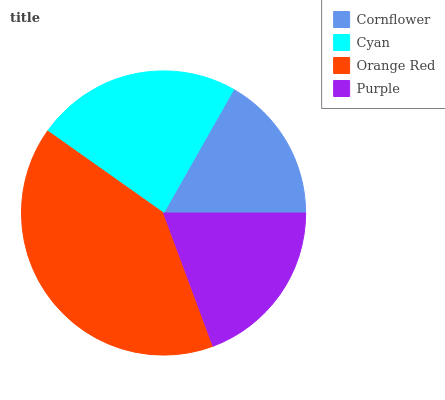Is Cornflower the minimum?
Answer yes or no. Yes. Is Orange Red the maximum?
Answer yes or no. Yes. Is Cyan the minimum?
Answer yes or no. No. Is Cyan the maximum?
Answer yes or no. No. Is Cyan greater than Cornflower?
Answer yes or no. Yes. Is Cornflower less than Cyan?
Answer yes or no. Yes. Is Cornflower greater than Cyan?
Answer yes or no. No. Is Cyan less than Cornflower?
Answer yes or no. No. Is Cyan the high median?
Answer yes or no. Yes. Is Purple the low median?
Answer yes or no. Yes. Is Purple the high median?
Answer yes or no. No. Is Cyan the low median?
Answer yes or no. No. 